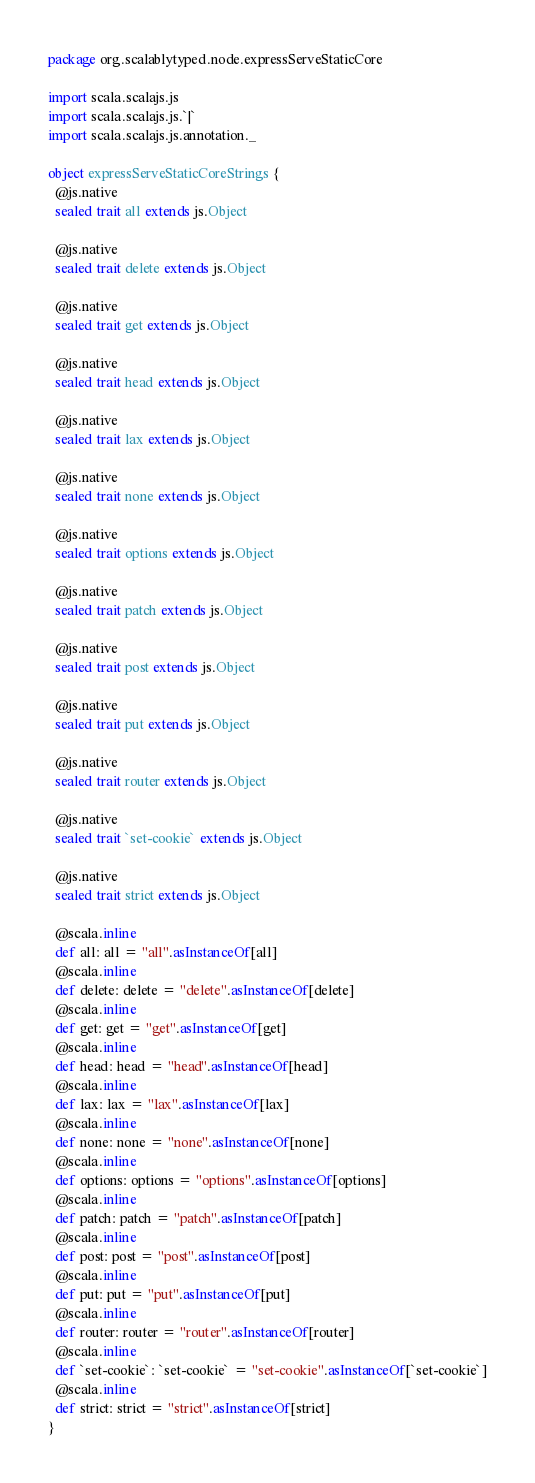<code> <loc_0><loc_0><loc_500><loc_500><_Scala_>package org.scalablytyped.node.expressServeStaticCore

import scala.scalajs.js
import scala.scalajs.js.`|`
import scala.scalajs.js.annotation._

object expressServeStaticCoreStrings {
  @js.native
  sealed trait all extends js.Object
  
  @js.native
  sealed trait delete extends js.Object
  
  @js.native
  sealed trait get extends js.Object
  
  @js.native
  sealed trait head extends js.Object
  
  @js.native
  sealed trait lax extends js.Object
  
  @js.native
  sealed trait none extends js.Object
  
  @js.native
  sealed trait options extends js.Object
  
  @js.native
  sealed trait patch extends js.Object
  
  @js.native
  sealed trait post extends js.Object
  
  @js.native
  sealed trait put extends js.Object
  
  @js.native
  sealed trait router extends js.Object
  
  @js.native
  sealed trait `set-cookie` extends js.Object
  
  @js.native
  sealed trait strict extends js.Object
  
  @scala.inline
  def all: all = "all".asInstanceOf[all]
  @scala.inline
  def delete: delete = "delete".asInstanceOf[delete]
  @scala.inline
  def get: get = "get".asInstanceOf[get]
  @scala.inline
  def head: head = "head".asInstanceOf[head]
  @scala.inline
  def lax: lax = "lax".asInstanceOf[lax]
  @scala.inline
  def none: none = "none".asInstanceOf[none]
  @scala.inline
  def options: options = "options".asInstanceOf[options]
  @scala.inline
  def patch: patch = "patch".asInstanceOf[patch]
  @scala.inline
  def post: post = "post".asInstanceOf[post]
  @scala.inline
  def put: put = "put".asInstanceOf[put]
  @scala.inline
  def router: router = "router".asInstanceOf[router]
  @scala.inline
  def `set-cookie`: `set-cookie` = "set-cookie".asInstanceOf[`set-cookie`]
  @scala.inline
  def strict: strict = "strict".asInstanceOf[strict]
}

</code> 